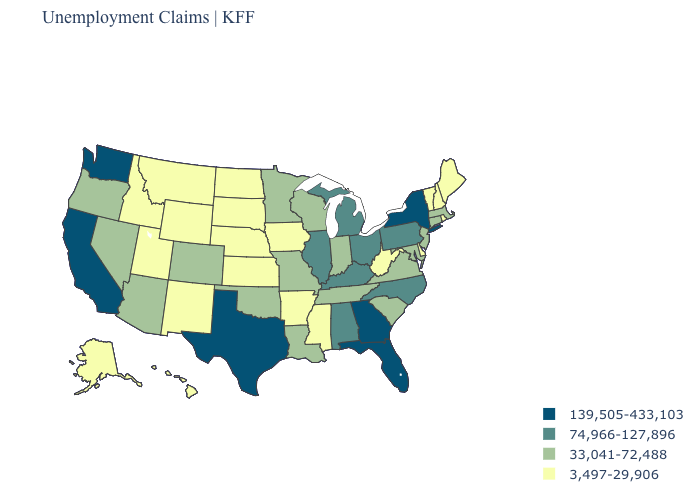What is the value of Louisiana?
Answer briefly. 33,041-72,488. Name the states that have a value in the range 3,497-29,906?
Answer briefly. Alaska, Arkansas, Delaware, Hawaii, Idaho, Iowa, Kansas, Maine, Mississippi, Montana, Nebraska, New Hampshire, New Mexico, North Dakota, Rhode Island, South Dakota, Utah, Vermont, West Virginia, Wyoming. What is the lowest value in the USA?
Concise answer only. 3,497-29,906. Name the states that have a value in the range 3,497-29,906?
Be succinct. Alaska, Arkansas, Delaware, Hawaii, Idaho, Iowa, Kansas, Maine, Mississippi, Montana, Nebraska, New Hampshire, New Mexico, North Dakota, Rhode Island, South Dakota, Utah, Vermont, West Virginia, Wyoming. What is the lowest value in the South?
Concise answer only. 3,497-29,906. What is the value of Hawaii?
Be succinct. 3,497-29,906. What is the lowest value in states that border Rhode Island?
Short answer required. 33,041-72,488. Which states have the lowest value in the MidWest?
Write a very short answer. Iowa, Kansas, Nebraska, North Dakota, South Dakota. Does the first symbol in the legend represent the smallest category?
Quick response, please. No. Does Florida have the highest value in the South?
Write a very short answer. Yes. Does Washington have the lowest value in the USA?
Keep it brief. No. Does the first symbol in the legend represent the smallest category?
Short answer required. No. What is the lowest value in the South?
Give a very brief answer. 3,497-29,906. Is the legend a continuous bar?
Keep it brief. No. How many symbols are there in the legend?
Answer briefly. 4. 